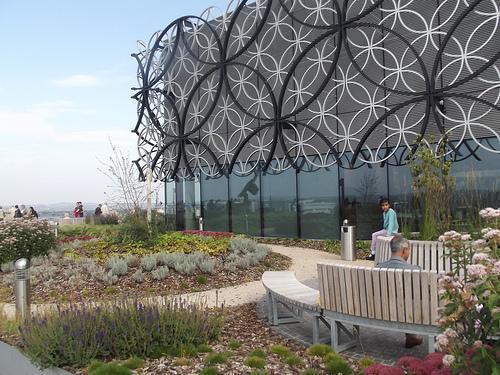How many girls sitting by the plant?
Give a very brief answer. 1. 